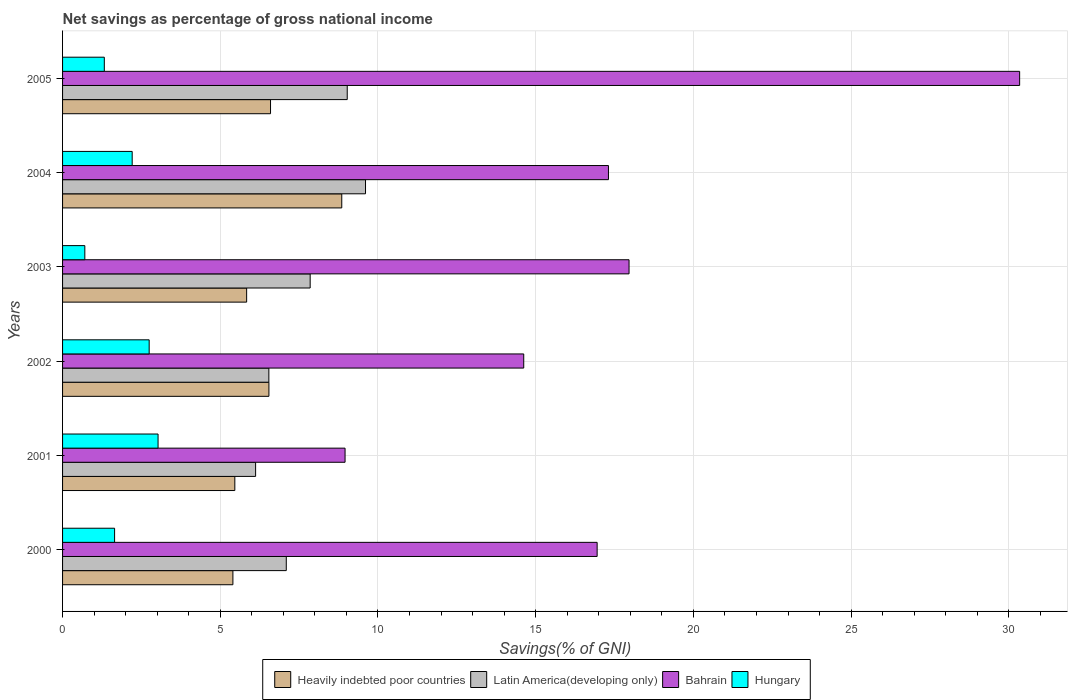How many groups of bars are there?
Offer a very short reply. 6. Are the number of bars on each tick of the Y-axis equal?
Provide a succinct answer. Yes. How many bars are there on the 3rd tick from the top?
Ensure brevity in your answer.  4. What is the label of the 2nd group of bars from the top?
Make the answer very short. 2004. In how many cases, is the number of bars for a given year not equal to the number of legend labels?
Make the answer very short. 0. What is the total savings in Bahrain in 2002?
Offer a terse response. 14.62. Across all years, what is the maximum total savings in Bahrain?
Your answer should be very brief. 30.34. Across all years, what is the minimum total savings in Heavily indebted poor countries?
Ensure brevity in your answer.  5.4. What is the total total savings in Hungary in the graph?
Ensure brevity in your answer.  11.66. What is the difference between the total savings in Bahrain in 2000 and that in 2001?
Provide a short and direct response. 7.99. What is the difference between the total savings in Bahrain in 2004 and the total savings in Latin America(developing only) in 2003?
Provide a succinct answer. 9.46. What is the average total savings in Latin America(developing only) per year?
Give a very brief answer. 7.71. In the year 2004, what is the difference between the total savings in Heavily indebted poor countries and total savings in Hungary?
Your answer should be compact. 6.64. In how many years, is the total savings in Latin America(developing only) greater than 8 %?
Your response must be concise. 2. What is the ratio of the total savings in Latin America(developing only) in 2002 to that in 2004?
Give a very brief answer. 0.68. Is the total savings in Hungary in 2000 less than that in 2005?
Provide a succinct answer. No. What is the difference between the highest and the second highest total savings in Heavily indebted poor countries?
Provide a short and direct response. 2.26. What is the difference between the highest and the lowest total savings in Hungary?
Your answer should be very brief. 2.32. Is the sum of the total savings in Latin America(developing only) in 2000 and 2003 greater than the maximum total savings in Hungary across all years?
Your answer should be compact. Yes. Is it the case that in every year, the sum of the total savings in Hungary and total savings in Latin America(developing only) is greater than the sum of total savings in Bahrain and total savings in Heavily indebted poor countries?
Make the answer very short. Yes. What does the 2nd bar from the top in 2003 represents?
Keep it short and to the point. Bahrain. What does the 4th bar from the bottom in 2003 represents?
Your answer should be compact. Hungary. How many bars are there?
Keep it short and to the point. 24. Are all the bars in the graph horizontal?
Give a very brief answer. Yes. How many years are there in the graph?
Provide a short and direct response. 6. Are the values on the major ticks of X-axis written in scientific E-notation?
Keep it short and to the point. No. Does the graph contain any zero values?
Offer a very short reply. No. Does the graph contain grids?
Your response must be concise. Yes. How are the legend labels stacked?
Give a very brief answer. Horizontal. What is the title of the graph?
Keep it short and to the point. Net savings as percentage of gross national income. Does "Maldives" appear as one of the legend labels in the graph?
Ensure brevity in your answer.  No. What is the label or title of the X-axis?
Provide a short and direct response. Savings(% of GNI). What is the label or title of the Y-axis?
Make the answer very short. Years. What is the Savings(% of GNI) of Heavily indebted poor countries in 2000?
Offer a very short reply. 5.4. What is the Savings(% of GNI) in Latin America(developing only) in 2000?
Your response must be concise. 7.09. What is the Savings(% of GNI) of Bahrain in 2000?
Provide a short and direct response. 16.95. What is the Savings(% of GNI) in Hungary in 2000?
Offer a very short reply. 1.65. What is the Savings(% of GNI) in Heavily indebted poor countries in 2001?
Provide a succinct answer. 5.46. What is the Savings(% of GNI) of Latin America(developing only) in 2001?
Your answer should be very brief. 6.12. What is the Savings(% of GNI) in Bahrain in 2001?
Your answer should be compact. 8.96. What is the Savings(% of GNI) of Hungary in 2001?
Offer a terse response. 3.03. What is the Savings(% of GNI) of Heavily indebted poor countries in 2002?
Keep it short and to the point. 6.54. What is the Savings(% of GNI) in Latin America(developing only) in 2002?
Offer a terse response. 6.54. What is the Savings(% of GNI) of Bahrain in 2002?
Your response must be concise. 14.62. What is the Savings(% of GNI) of Hungary in 2002?
Keep it short and to the point. 2.75. What is the Savings(% of GNI) in Heavily indebted poor countries in 2003?
Keep it short and to the point. 5.84. What is the Savings(% of GNI) in Latin America(developing only) in 2003?
Provide a short and direct response. 7.85. What is the Savings(% of GNI) of Bahrain in 2003?
Your response must be concise. 17.96. What is the Savings(% of GNI) in Hungary in 2003?
Give a very brief answer. 0.71. What is the Savings(% of GNI) in Heavily indebted poor countries in 2004?
Offer a terse response. 8.85. What is the Savings(% of GNI) of Latin America(developing only) in 2004?
Your answer should be compact. 9.6. What is the Savings(% of GNI) of Bahrain in 2004?
Provide a succinct answer. 17.31. What is the Savings(% of GNI) of Hungary in 2004?
Provide a succinct answer. 2.21. What is the Savings(% of GNI) of Heavily indebted poor countries in 2005?
Your answer should be very brief. 6.59. What is the Savings(% of GNI) of Latin America(developing only) in 2005?
Your answer should be compact. 9.02. What is the Savings(% of GNI) of Bahrain in 2005?
Make the answer very short. 30.34. What is the Savings(% of GNI) of Hungary in 2005?
Offer a very short reply. 1.32. Across all years, what is the maximum Savings(% of GNI) of Heavily indebted poor countries?
Your answer should be very brief. 8.85. Across all years, what is the maximum Savings(% of GNI) in Latin America(developing only)?
Give a very brief answer. 9.6. Across all years, what is the maximum Savings(% of GNI) of Bahrain?
Your answer should be very brief. 30.34. Across all years, what is the maximum Savings(% of GNI) in Hungary?
Your response must be concise. 3.03. Across all years, what is the minimum Savings(% of GNI) in Heavily indebted poor countries?
Keep it short and to the point. 5.4. Across all years, what is the minimum Savings(% of GNI) of Latin America(developing only)?
Make the answer very short. 6.12. Across all years, what is the minimum Savings(% of GNI) of Bahrain?
Ensure brevity in your answer.  8.96. Across all years, what is the minimum Savings(% of GNI) in Hungary?
Ensure brevity in your answer.  0.71. What is the total Savings(% of GNI) in Heavily indebted poor countries in the graph?
Give a very brief answer. 38.68. What is the total Savings(% of GNI) in Latin America(developing only) in the graph?
Ensure brevity in your answer.  46.23. What is the total Savings(% of GNI) of Bahrain in the graph?
Provide a short and direct response. 106.13. What is the total Savings(% of GNI) of Hungary in the graph?
Make the answer very short. 11.66. What is the difference between the Savings(% of GNI) in Heavily indebted poor countries in 2000 and that in 2001?
Keep it short and to the point. -0.06. What is the difference between the Savings(% of GNI) of Latin America(developing only) in 2000 and that in 2001?
Keep it short and to the point. 0.97. What is the difference between the Savings(% of GNI) of Bahrain in 2000 and that in 2001?
Provide a succinct answer. 7.99. What is the difference between the Savings(% of GNI) of Hungary in 2000 and that in 2001?
Provide a short and direct response. -1.38. What is the difference between the Savings(% of GNI) of Heavily indebted poor countries in 2000 and that in 2002?
Keep it short and to the point. -1.14. What is the difference between the Savings(% of GNI) of Latin America(developing only) in 2000 and that in 2002?
Give a very brief answer. 0.55. What is the difference between the Savings(% of GNI) in Bahrain in 2000 and that in 2002?
Provide a succinct answer. 2.33. What is the difference between the Savings(% of GNI) of Hungary in 2000 and that in 2002?
Make the answer very short. -1.1. What is the difference between the Savings(% of GNI) of Heavily indebted poor countries in 2000 and that in 2003?
Give a very brief answer. -0.44. What is the difference between the Savings(% of GNI) of Latin America(developing only) in 2000 and that in 2003?
Offer a terse response. -0.76. What is the difference between the Savings(% of GNI) in Bahrain in 2000 and that in 2003?
Provide a short and direct response. -1.01. What is the difference between the Savings(% of GNI) in Hungary in 2000 and that in 2003?
Your answer should be very brief. 0.94. What is the difference between the Savings(% of GNI) in Heavily indebted poor countries in 2000 and that in 2004?
Ensure brevity in your answer.  -3.45. What is the difference between the Savings(% of GNI) in Latin America(developing only) in 2000 and that in 2004?
Provide a succinct answer. -2.51. What is the difference between the Savings(% of GNI) of Bahrain in 2000 and that in 2004?
Provide a succinct answer. -0.36. What is the difference between the Savings(% of GNI) in Hungary in 2000 and that in 2004?
Give a very brief answer. -0.56. What is the difference between the Savings(% of GNI) of Heavily indebted poor countries in 2000 and that in 2005?
Make the answer very short. -1.19. What is the difference between the Savings(% of GNI) of Latin America(developing only) in 2000 and that in 2005?
Your response must be concise. -1.93. What is the difference between the Savings(% of GNI) in Bahrain in 2000 and that in 2005?
Provide a short and direct response. -13.39. What is the difference between the Savings(% of GNI) of Hungary in 2000 and that in 2005?
Give a very brief answer. 0.33. What is the difference between the Savings(% of GNI) of Heavily indebted poor countries in 2001 and that in 2002?
Your response must be concise. -1.08. What is the difference between the Savings(% of GNI) in Latin America(developing only) in 2001 and that in 2002?
Your answer should be very brief. -0.42. What is the difference between the Savings(% of GNI) of Bahrain in 2001 and that in 2002?
Your answer should be compact. -5.66. What is the difference between the Savings(% of GNI) of Hungary in 2001 and that in 2002?
Give a very brief answer. 0.28. What is the difference between the Savings(% of GNI) in Heavily indebted poor countries in 2001 and that in 2003?
Your response must be concise. -0.37. What is the difference between the Savings(% of GNI) of Latin America(developing only) in 2001 and that in 2003?
Give a very brief answer. -1.73. What is the difference between the Savings(% of GNI) of Bahrain in 2001 and that in 2003?
Provide a short and direct response. -9. What is the difference between the Savings(% of GNI) of Hungary in 2001 and that in 2003?
Make the answer very short. 2.32. What is the difference between the Savings(% of GNI) in Heavily indebted poor countries in 2001 and that in 2004?
Provide a short and direct response. -3.39. What is the difference between the Savings(% of GNI) of Latin America(developing only) in 2001 and that in 2004?
Keep it short and to the point. -3.48. What is the difference between the Savings(% of GNI) of Bahrain in 2001 and that in 2004?
Ensure brevity in your answer.  -8.35. What is the difference between the Savings(% of GNI) in Hungary in 2001 and that in 2004?
Offer a very short reply. 0.82. What is the difference between the Savings(% of GNI) in Heavily indebted poor countries in 2001 and that in 2005?
Your answer should be very brief. -1.13. What is the difference between the Savings(% of GNI) of Latin America(developing only) in 2001 and that in 2005?
Your response must be concise. -2.9. What is the difference between the Savings(% of GNI) of Bahrain in 2001 and that in 2005?
Offer a terse response. -21.39. What is the difference between the Savings(% of GNI) in Hungary in 2001 and that in 2005?
Offer a terse response. 1.7. What is the difference between the Savings(% of GNI) in Heavily indebted poor countries in 2002 and that in 2003?
Your response must be concise. 0.71. What is the difference between the Savings(% of GNI) of Latin America(developing only) in 2002 and that in 2003?
Your response must be concise. -1.31. What is the difference between the Savings(% of GNI) in Bahrain in 2002 and that in 2003?
Make the answer very short. -3.34. What is the difference between the Savings(% of GNI) in Hungary in 2002 and that in 2003?
Your answer should be compact. 2.04. What is the difference between the Savings(% of GNI) in Heavily indebted poor countries in 2002 and that in 2004?
Give a very brief answer. -2.31. What is the difference between the Savings(% of GNI) of Latin America(developing only) in 2002 and that in 2004?
Your answer should be very brief. -3.06. What is the difference between the Savings(% of GNI) in Bahrain in 2002 and that in 2004?
Keep it short and to the point. -2.69. What is the difference between the Savings(% of GNI) of Hungary in 2002 and that in 2004?
Provide a succinct answer. 0.54. What is the difference between the Savings(% of GNI) of Heavily indebted poor countries in 2002 and that in 2005?
Keep it short and to the point. -0.05. What is the difference between the Savings(% of GNI) of Latin America(developing only) in 2002 and that in 2005?
Provide a short and direct response. -2.48. What is the difference between the Savings(% of GNI) of Bahrain in 2002 and that in 2005?
Give a very brief answer. -15.72. What is the difference between the Savings(% of GNI) in Hungary in 2002 and that in 2005?
Provide a short and direct response. 1.42. What is the difference between the Savings(% of GNI) in Heavily indebted poor countries in 2003 and that in 2004?
Provide a succinct answer. -3.02. What is the difference between the Savings(% of GNI) in Latin America(developing only) in 2003 and that in 2004?
Ensure brevity in your answer.  -1.75. What is the difference between the Savings(% of GNI) of Bahrain in 2003 and that in 2004?
Offer a terse response. 0.65. What is the difference between the Savings(% of GNI) of Hungary in 2003 and that in 2004?
Make the answer very short. -1.5. What is the difference between the Savings(% of GNI) of Heavily indebted poor countries in 2003 and that in 2005?
Ensure brevity in your answer.  -0.76. What is the difference between the Savings(% of GNI) of Latin America(developing only) in 2003 and that in 2005?
Give a very brief answer. -1.17. What is the difference between the Savings(% of GNI) in Bahrain in 2003 and that in 2005?
Your answer should be compact. -12.38. What is the difference between the Savings(% of GNI) of Hungary in 2003 and that in 2005?
Your answer should be compact. -0.62. What is the difference between the Savings(% of GNI) in Heavily indebted poor countries in 2004 and that in 2005?
Provide a succinct answer. 2.26. What is the difference between the Savings(% of GNI) of Latin America(developing only) in 2004 and that in 2005?
Make the answer very short. 0.58. What is the difference between the Savings(% of GNI) of Bahrain in 2004 and that in 2005?
Provide a short and direct response. -13.04. What is the difference between the Savings(% of GNI) in Hungary in 2004 and that in 2005?
Make the answer very short. 0.88. What is the difference between the Savings(% of GNI) of Heavily indebted poor countries in 2000 and the Savings(% of GNI) of Latin America(developing only) in 2001?
Give a very brief answer. -0.72. What is the difference between the Savings(% of GNI) in Heavily indebted poor countries in 2000 and the Savings(% of GNI) in Bahrain in 2001?
Ensure brevity in your answer.  -3.56. What is the difference between the Savings(% of GNI) in Heavily indebted poor countries in 2000 and the Savings(% of GNI) in Hungary in 2001?
Keep it short and to the point. 2.37. What is the difference between the Savings(% of GNI) in Latin America(developing only) in 2000 and the Savings(% of GNI) in Bahrain in 2001?
Offer a terse response. -1.86. What is the difference between the Savings(% of GNI) of Latin America(developing only) in 2000 and the Savings(% of GNI) of Hungary in 2001?
Keep it short and to the point. 4.06. What is the difference between the Savings(% of GNI) in Bahrain in 2000 and the Savings(% of GNI) in Hungary in 2001?
Provide a short and direct response. 13.92. What is the difference between the Savings(% of GNI) of Heavily indebted poor countries in 2000 and the Savings(% of GNI) of Latin America(developing only) in 2002?
Offer a terse response. -1.14. What is the difference between the Savings(% of GNI) in Heavily indebted poor countries in 2000 and the Savings(% of GNI) in Bahrain in 2002?
Make the answer very short. -9.22. What is the difference between the Savings(% of GNI) in Heavily indebted poor countries in 2000 and the Savings(% of GNI) in Hungary in 2002?
Provide a succinct answer. 2.65. What is the difference between the Savings(% of GNI) in Latin America(developing only) in 2000 and the Savings(% of GNI) in Bahrain in 2002?
Keep it short and to the point. -7.53. What is the difference between the Savings(% of GNI) in Latin America(developing only) in 2000 and the Savings(% of GNI) in Hungary in 2002?
Offer a terse response. 4.35. What is the difference between the Savings(% of GNI) in Bahrain in 2000 and the Savings(% of GNI) in Hungary in 2002?
Your response must be concise. 14.2. What is the difference between the Savings(% of GNI) in Heavily indebted poor countries in 2000 and the Savings(% of GNI) in Latin America(developing only) in 2003?
Give a very brief answer. -2.45. What is the difference between the Savings(% of GNI) in Heavily indebted poor countries in 2000 and the Savings(% of GNI) in Bahrain in 2003?
Your answer should be very brief. -12.56. What is the difference between the Savings(% of GNI) in Heavily indebted poor countries in 2000 and the Savings(% of GNI) in Hungary in 2003?
Your answer should be very brief. 4.69. What is the difference between the Savings(% of GNI) in Latin America(developing only) in 2000 and the Savings(% of GNI) in Bahrain in 2003?
Give a very brief answer. -10.87. What is the difference between the Savings(% of GNI) of Latin America(developing only) in 2000 and the Savings(% of GNI) of Hungary in 2003?
Your response must be concise. 6.39. What is the difference between the Savings(% of GNI) in Bahrain in 2000 and the Savings(% of GNI) in Hungary in 2003?
Offer a very short reply. 16.24. What is the difference between the Savings(% of GNI) in Heavily indebted poor countries in 2000 and the Savings(% of GNI) in Latin America(developing only) in 2004?
Make the answer very short. -4.2. What is the difference between the Savings(% of GNI) in Heavily indebted poor countries in 2000 and the Savings(% of GNI) in Bahrain in 2004?
Keep it short and to the point. -11.91. What is the difference between the Savings(% of GNI) of Heavily indebted poor countries in 2000 and the Savings(% of GNI) of Hungary in 2004?
Your response must be concise. 3.19. What is the difference between the Savings(% of GNI) of Latin America(developing only) in 2000 and the Savings(% of GNI) of Bahrain in 2004?
Provide a succinct answer. -10.21. What is the difference between the Savings(% of GNI) in Latin America(developing only) in 2000 and the Savings(% of GNI) in Hungary in 2004?
Give a very brief answer. 4.88. What is the difference between the Savings(% of GNI) in Bahrain in 2000 and the Savings(% of GNI) in Hungary in 2004?
Provide a succinct answer. 14.74. What is the difference between the Savings(% of GNI) of Heavily indebted poor countries in 2000 and the Savings(% of GNI) of Latin America(developing only) in 2005?
Offer a very short reply. -3.62. What is the difference between the Savings(% of GNI) of Heavily indebted poor countries in 2000 and the Savings(% of GNI) of Bahrain in 2005?
Provide a short and direct response. -24.94. What is the difference between the Savings(% of GNI) of Heavily indebted poor countries in 2000 and the Savings(% of GNI) of Hungary in 2005?
Keep it short and to the point. 4.08. What is the difference between the Savings(% of GNI) of Latin America(developing only) in 2000 and the Savings(% of GNI) of Bahrain in 2005?
Give a very brief answer. -23.25. What is the difference between the Savings(% of GNI) in Latin America(developing only) in 2000 and the Savings(% of GNI) in Hungary in 2005?
Offer a very short reply. 5.77. What is the difference between the Savings(% of GNI) of Bahrain in 2000 and the Savings(% of GNI) of Hungary in 2005?
Your answer should be very brief. 15.62. What is the difference between the Savings(% of GNI) of Heavily indebted poor countries in 2001 and the Savings(% of GNI) of Latin America(developing only) in 2002?
Provide a succinct answer. -1.08. What is the difference between the Savings(% of GNI) in Heavily indebted poor countries in 2001 and the Savings(% of GNI) in Bahrain in 2002?
Provide a succinct answer. -9.16. What is the difference between the Savings(% of GNI) in Heavily indebted poor countries in 2001 and the Savings(% of GNI) in Hungary in 2002?
Make the answer very short. 2.72. What is the difference between the Savings(% of GNI) in Latin America(developing only) in 2001 and the Savings(% of GNI) in Hungary in 2002?
Your answer should be very brief. 3.37. What is the difference between the Savings(% of GNI) in Bahrain in 2001 and the Savings(% of GNI) in Hungary in 2002?
Provide a succinct answer. 6.21. What is the difference between the Savings(% of GNI) in Heavily indebted poor countries in 2001 and the Savings(% of GNI) in Latin America(developing only) in 2003?
Your answer should be compact. -2.39. What is the difference between the Savings(% of GNI) in Heavily indebted poor countries in 2001 and the Savings(% of GNI) in Bahrain in 2003?
Your answer should be very brief. -12.5. What is the difference between the Savings(% of GNI) of Heavily indebted poor countries in 2001 and the Savings(% of GNI) of Hungary in 2003?
Provide a succinct answer. 4.76. What is the difference between the Savings(% of GNI) in Latin America(developing only) in 2001 and the Savings(% of GNI) in Bahrain in 2003?
Offer a very short reply. -11.84. What is the difference between the Savings(% of GNI) of Latin America(developing only) in 2001 and the Savings(% of GNI) of Hungary in 2003?
Give a very brief answer. 5.41. What is the difference between the Savings(% of GNI) of Bahrain in 2001 and the Savings(% of GNI) of Hungary in 2003?
Ensure brevity in your answer.  8.25. What is the difference between the Savings(% of GNI) of Heavily indebted poor countries in 2001 and the Savings(% of GNI) of Latin America(developing only) in 2004?
Keep it short and to the point. -4.14. What is the difference between the Savings(% of GNI) of Heavily indebted poor countries in 2001 and the Savings(% of GNI) of Bahrain in 2004?
Keep it short and to the point. -11.85. What is the difference between the Savings(% of GNI) in Heavily indebted poor countries in 2001 and the Savings(% of GNI) in Hungary in 2004?
Keep it short and to the point. 3.25. What is the difference between the Savings(% of GNI) of Latin America(developing only) in 2001 and the Savings(% of GNI) of Bahrain in 2004?
Ensure brevity in your answer.  -11.19. What is the difference between the Savings(% of GNI) in Latin America(developing only) in 2001 and the Savings(% of GNI) in Hungary in 2004?
Provide a short and direct response. 3.91. What is the difference between the Savings(% of GNI) of Bahrain in 2001 and the Savings(% of GNI) of Hungary in 2004?
Your response must be concise. 6.75. What is the difference between the Savings(% of GNI) in Heavily indebted poor countries in 2001 and the Savings(% of GNI) in Latin America(developing only) in 2005?
Offer a terse response. -3.56. What is the difference between the Savings(% of GNI) of Heavily indebted poor countries in 2001 and the Savings(% of GNI) of Bahrain in 2005?
Ensure brevity in your answer.  -24.88. What is the difference between the Savings(% of GNI) of Heavily indebted poor countries in 2001 and the Savings(% of GNI) of Hungary in 2005?
Offer a terse response. 4.14. What is the difference between the Savings(% of GNI) in Latin America(developing only) in 2001 and the Savings(% of GNI) in Bahrain in 2005?
Give a very brief answer. -24.22. What is the difference between the Savings(% of GNI) in Latin America(developing only) in 2001 and the Savings(% of GNI) in Hungary in 2005?
Make the answer very short. 4.8. What is the difference between the Savings(% of GNI) of Bahrain in 2001 and the Savings(% of GNI) of Hungary in 2005?
Your answer should be very brief. 7.63. What is the difference between the Savings(% of GNI) of Heavily indebted poor countries in 2002 and the Savings(% of GNI) of Latin America(developing only) in 2003?
Keep it short and to the point. -1.31. What is the difference between the Savings(% of GNI) of Heavily indebted poor countries in 2002 and the Savings(% of GNI) of Bahrain in 2003?
Your response must be concise. -11.42. What is the difference between the Savings(% of GNI) in Heavily indebted poor countries in 2002 and the Savings(% of GNI) in Hungary in 2003?
Your answer should be very brief. 5.84. What is the difference between the Savings(% of GNI) in Latin America(developing only) in 2002 and the Savings(% of GNI) in Bahrain in 2003?
Keep it short and to the point. -11.42. What is the difference between the Savings(% of GNI) in Latin America(developing only) in 2002 and the Savings(% of GNI) in Hungary in 2003?
Your response must be concise. 5.83. What is the difference between the Savings(% of GNI) in Bahrain in 2002 and the Savings(% of GNI) in Hungary in 2003?
Offer a terse response. 13.91. What is the difference between the Savings(% of GNI) in Heavily indebted poor countries in 2002 and the Savings(% of GNI) in Latin America(developing only) in 2004?
Your response must be concise. -3.06. What is the difference between the Savings(% of GNI) in Heavily indebted poor countries in 2002 and the Savings(% of GNI) in Bahrain in 2004?
Keep it short and to the point. -10.76. What is the difference between the Savings(% of GNI) in Heavily indebted poor countries in 2002 and the Savings(% of GNI) in Hungary in 2004?
Keep it short and to the point. 4.33. What is the difference between the Savings(% of GNI) in Latin America(developing only) in 2002 and the Savings(% of GNI) in Bahrain in 2004?
Offer a very short reply. -10.77. What is the difference between the Savings(% of GNI) of Latin America(developing only) in 2002 and the Savings(% of GNI) of Hungary in 2004?
Give a very brief answer. 4.33. What is the difference between the Savings(% of GNI) in Bahrain in 2002 and the Savings(% of GNI) in Hungary in 2004?
Offer a terse response. 12.41. What is the difference between the Savings(% of GNI) of Heavily indebted poor countries in 2002 and the Savings(% of GNI) of Latin America(developing only) in 2005?
Offer a terse response. -2.48. What is the difference between the Savings(% of GNI) in Heavily indebted poor countries in 2002 and the Savings(% of GNI) in Bahrain in 2005?
Your answer should be compact. -23.8. What is the difference between the Savings(% of GNI) in Heavily indebted poor countries in 2002 and the Savings(% of GNI) in Hungary in 2005?
Your response must be concise. 5.22. What is the difference between the Savings(% of GNI) of Latin America(developing only) in 2002 and the Savings(% of GNI) of Bahrain in 2005?
Provide a short and direct response. -23.8. What is the difference between the Savings(% of GNI) of Latin America(developing only) in 2002 and the Savings(% of GNI) of Hungary in 2005?
Your answer should be very brief. 5.22. What is the difference between the Savings(% of GNI) of Bahrain in 2002 and the Savings(% of GNI) of Hungary in 2005?
Your response must be concise. 13.3. What is the difference between the Savings(% of GNI) in Heavily indebted poor countries in 2003 and the Savings(% of GNI) in Latin America(developing only) in 2004?
Give a very brief answer. -3.77. What is the difference between the Savings(% of GNI) of Heavily indebted poor countries in 2003 and the Savings(% of GNI) of Bahrain in 2004?
Your answer should be compact. -11.47. What is the difference between the Savings(% of GNI) of Heavily indebted poor countries in 2003 and the Savings(% of GNI) of Hungary in 2004?
Make the answer very short. 3.63. What is the difference between the Savings(% of GNI) of Latin America(developing only) in 2003 and the Savings(% of GNI) of Bahrain in 2004?
Offer a terse response. -9.46. What is the difference between the Savings(% of GNI) in Latin America(developing only) in 2003 and the Savings(% of GNI) in Hungary in 2004?
Offer a very short reply. 5.64. What is the difference between the Savings(% of GNI) in Bahrain in 2003 and the Savings(% of GNI) in Hungary in 2004?
Provide a succinct answer. 15.75. What is the difference between the Savings(% of GNI) of Heavily indebted poor countries in 2003 and the Savings(% of GNI) of Latin America(developing only) in 2005?
Offer a very short reply. -3.19. What is the difference between the Savings(% of GNI) in Heavily indebted poor countries in 2003 and the Savings(% of GNI) in Bahrain in 2005?
Give a very brief answer. -24.51. What is the difference between the Savings(% of GNI) in Heavily indebted poor countries in 2003 and the Savings(% of GNI) in Hungary in 2005?
Your answer should be compact. 4.51. What is the difference between the Savings(% of GNI) of Latin America(developing only) in 2003 and the Savings(% of GNI) of Bahrain in 2005?
Offer a terse response. -22.49. What is the difference between the Savings(% of GNI) in Latin America(developing only) in 2003 and the Savings(% of GNI) in Hungary in 2005?
Your response must be concise. 6.53. What is the difference between the Savings(% of GNI) of Bahrain in 2003 and the Savings(% of GNI) of Hungary in 2005?
Provide a short and direct response. 16.64. What is the difference between the Savings(% of GNI) in Heavily indebted poor countries in 2004 and the Savings(% of GNI) in Latin America(developing only) in 2005?
Ensure brevity in your answer.  -0.17. What is the difference between the Savings(% of GNI) in Heavily indebted poor countries in 2004 and the Savings(% of GNI) in Bahrain in 2005?
Provide a succinct answer. -21.49. What is the difference between the Savings(% of GNI) in Heavily indebted poor countries in 2004 and the Savings(% of GNI) in Hungary in 2005?
Offer a very short reply. 7.53. What is the difference between the Savings(% of GNI) of Latin America(developing only) in 2004 and the Savings(% of GNI) of Bahrain in 2005?
Give a very brief answer. -20.74. What is the difference between the Savings(% of GNI) in Latin America(developing only) in 2004 and the Savings(% of GNI) in Hungary in 2005?
Your answer should be compact. 8.28. What is the difference between the Savings(% of GNI) in Bahrain in 2004 and the Savings(% of GNI) in Hungary in 2005?
Provide a short and direct response. 15.98. What is the average Savings(% of GNI) in Heavily indebted poor countries per year?
Offer a terse response. 6.45. What is the average Savings(% of GNI) of Latin America(developing only) per year?
Your response must be concise. 7.71. What is the average Savings(% of GNI) in Bahrain per year?
Offer a terse response. 17.69. What is the average Savings(% of GNI) in Hungary per year?
Ensure brevity in your answer.  1.94. In the year 2000, what is the difference between the Savings(% of GNI) in Heavily indebted poor countries and Savings(% of GNI) in Latin America(developing only)?
Provide a short and direct response. -1.69. In the year 2000, what is the difference between the Savings(% of GNI) of Heavily indebted poor countries and Savings(% of GNI) of Bahrain?
Offer a very short reply. -11.55. In the year 2000, what is the difference between the Savings(% of GNI) in Heavily indebted poor countries and Savings(% of GNI) in Hungary?
Make the answer very short. 3.75. In the year 2000, what is the difference between the Savings(% of GNI) in Latin America(developing only) and Savings(% of GNI) in Bahrain?
Make the answer very short. -9.86. In the year 2000, what is the difference between the Savings(% of GNI) of Latin America(developing only) and Savings(% of GNI) of Hungary?
Offer a terse response. 5.44. In the year 2000, what is the difference between the Savings(% of GNI) of Bahrain and Savings(% of GNI) of Hungary?
Your response must be concise. 15.3. In the year 2001, what is the difference between the Savings(% of GNI) in Heavily indebted poor countries and Savings(% of GNI) in Latin America(developing only)?
Ensure brevity in your answer.  -0.66. In the year 2001, what is the difference between the Savings(% of GNI) in Heavily indebted poor countries and Savings(% of GNI) in Bahrain?
Offer a very short reply. -3.49. In the year 2001, what is the difference between the Savings(% of GNI) in Heavily indebted poor countries and Savings(% of GNI) in Hungary?
Make the answer very short. 2.43. In the year 2001, what is the difference between the Savings(% of GNI) in Latin America(developing only) and Savings(% of GNI) in Bahrain?
Give a very brief answer. -2.84. In the year 2001, what is the difference between the Savings(% of GNI) of Latin America(developing only) and Savings(% of GNI) of Hungary?
Your answer should be compact. 3.09. In the year 2001, what is the difference between the Savings(% of GNI) in Bahrain and Savings(% of GNI) in Hungary?
Your answer should be compact. 5.93. In the year 2002, what is the difference between the Savings(% of GNI) of Heavily indebted poor countries and Savings(% of GNI) of Latin America(developing only)?
Your answer should be very brief. 0. In the year 2002, what is the difference between the Savings(% of GNI) in Heavily indebted poor countries and Savings(% of GNI) in Bahrain?
Your answer should be very brief. -8.08. In the year 2002, what is the difference between the Savings(% of GNI) in Heavily indebted poor countries and Savings(% of GNI) in Hungary?
Offer a very short reply. 3.8. In the year 2002, what is the difference between the Savings(% of GNI) in Latin America(developing only) and Savings(% of GNI) in Bahrain?
Provide a succinct answer. -8.08. In the year 2002, what is the difference between the Savings(% of GNI) in Latin America(developing only) and Savings(% of GNI) in Hungary?
Your answer should be compact. 3.79. In the year 2002, what is the difference between the Savings(% of GNI) of Bahrain and Savings(% of GNI) of Hungary?
Provide a succinct answer. 11.87. In the year 2003, what is the difference between the Savings(% of GNI) of Heavily indebted poor countries and Savings(% of GNI) of Latin America(developing only)?
Make the answer very short. -2.01. In the year 2003, what is the difference between the Savings(% of GNI) in Heavily indebted poor countries and Savings(% of GNI) in Bahrain?
Make the answer very short. -12.12. In the year 2003, what is the difference between the Savings(% of GNI) in Heavily indebted poor countries and Savings(% of GNI) in Hungary?
Give a very brief answer. 5.13. In the year 2003, what is the difference between the Savings(% of GNI) of Latin America(developing only) and Savings(% of GNI) of Bahrain?
Offer a terse response. -10.11. In the year 2003, what is the difference between the Savings(% of GNI) in Latin America(developing only) and Savings(% of GNI) in Hungary?
Offer a terse response. 7.14. In the year 2003, what is the difference between the Savings(% of GNI) in Bahrain and Savings(% of GNI) in Hungary?
Offer a very short reply. 17.25. In the year 2004, what is the difference between the Savings(% of GNI) of Heavily indebted poor countries and Savings(% of GNI) of Latin America(developing only)?
Offer a terse response. -0.75. In the year 2004, what is the difference between the Savings(% of GNI) in Heavily indebted poor countries and Savings(% of GNI) in Bahrain?
Ensure brevity in your answer.  -8.45. In the year 2004, what is the difference between the Savings(% of GNI) of Heavily indebted poor countries and Savings(% of GNI) of Hungary?
Ensure brevity in your answer.  6.64. In the year 2004, what is the difference between the Savings(% of GNI) of Latin America(developing only) and Savings(% of GNI) of Bahrain?
Keep it short and to the point. -7.7. In the year 2004, what is the difference between the Savings(% of GNI) in Latin America(developing only) and Savings(% of GNI) in Hungary?
Your answer should be very brief. 7.4. In the year 2004, what is the difference between the Savings(% of GNI) in Bahrain and Savings(% of GNI) in Hungary?
Keep it short and to the point. 15.1. In the year 2005, what is the difference between the Savings(% of GNI) of Heavily indebted poor countries and Savings(% of GNI) of Latin America(developing only)?
Keep it short and to the point. -2.43. In the year 2005, what is the difference between the Savings(% of GNI) in Heavily indebted poor countries and Savings(% of GNI) in Bahrain?
Provide a short and direct response. -23.75. In the year 2005, what is the difference between the Savings(% of GNI) in Heavily indebted poor countries and Savings(% of GNI) in Hungary?
Offer a terse response. 5.27. In the year 2005, what is the difference between the Savings(% of GNI) in Latin America(developing only) and Savings(% of GNI) in Bahrain?
Offer a very short reply. -21.32. In the year 2005, what is the difference between the Savings(% of GNI) of Latin America(developing only) and Savings(% of GNI) of Hungary?
Make the answer very short. 7.7. In the year 2005, what is the difference between the Savings(% of GNI) in Bahrain and Savings(% of GNI) in Hungary?
Provide a short and direct response. 29.02. What is the ratio of the Savings(% of GNI) of Latin America(developing only) in 2000 to that in 2001?
Your answer should be compact. 1.16. What is the ratio of the Savings(% of GNI) of Bahrain in 2000 to that in 2001?
Your answer should be very brief. 1.89. What is the ratio of the Savings(% of GNI) in Hungary in 2000 to that in 2001?
Give a very brief answer. 0.54. What is the ratio of the Savings(% of GNI) of Heavily indebted poor countries in 2000 to that in 2002?
Your response must be concise. 0.83. What is the ratio of the Savings(% of GNI) of Latin America(developing only) in 2000 to that in 2002?
Offer a very short reply. 1.08. What is the ratio of the Savings(% of GNI) of Bahrain in 2000 to that in 2002?
Make the answer very short. 1.16. What is the ratio of the Savings(% of GNI) in Hungary in 2000 to that in 2002?
Offer a very short reply. 0.6. What is the ratio of the Savings(% of GNI) of Heavily indebted poor countries in 2000 to that in 2003?
Offer a terse response. 0.93. What is the ratio of the Savings(% of GNI) of Latin America(developing only) in 2000 to that in 2003?
Give a very brief answer. 0.9. What is the ratio of the Savings(% of GNI) in Bahrain in 2000 to that in 2003?
Keep it short and to the point. 0.94. What is the ratio of the Savings(% of GNI) of Hungary in 2000 to that in 2003?
Your answer should be compact. 2.34. What is the ratio of the Savings(% of GNI) of Heavily indebted poor countries in 2000 to that in 2004?
Provide a short and direct response. 0.61. What is the ratio of the Savings(% of GNI) in Latin America(developing only) in 2000 to that in 2004?
Provide a short and direct response. 0.74. What is the ratio of the Savings(% of GNI) in Bahrain in 2000 to that in 2004?
Ensure brevity in your answer.  0.98. What is the ratio of the Savings(% of GNI) of Hungary in 2000 to that in 2004?
Offer a terse response. 0.75. What is the ratio of the Savings(% of GNI) of Heavily indebted poor countries in 2000 to that in 2005?
Your answer should be compact. 0.82. What is the ratio of the Savings(% of GNI) in Latin America(developing only) in 2000 to that in 2005?
Keep it short and to the point. 0.79. What is the ratio of the Savings(% of GNI) in Bahrain in 2000 to that in 2005?
Your response must be concise. 0.56. What is the ratio of the Savings(% of GNI) of Hungary in 2000 to that in 2005?
Give a very brief answer. 1.25. What is the ratio of the Savings(% of GNI) of Heavily indebted poor countries in 2001 to that in 2002?
Provide a succinct answer. 0.83. What is the ratio of the Savings(% of GNI) of Latin America(developing only) in 2001 to that in 2002?
Offer a very short reply. 0.94. What is the ratio of the Savings(% of GNI) of Bahrain in 2001 to that in 2002?
Your answer should be compact. 0.61. What is the ratio of the Savings(% of GNI) of Hungary in 2001 to that in 2002?
Keep it short and to the point. 1.1. What is the ratio of the Savings(% of GNI) of Heavily indebted poor countries in 2001 to that in 2003?
Your answer should be very brief. 0.94. What is the ratio of the Savings(% of GNI) of Latin America(developing only) in 2001 to that in 2003?
Your answer should be very brief. 0.78. What is the ratio of the Savings(% of GNI) of Bahrain in 2001 to that in 2003?
Give a very brief answer. 0.5. What is the ratio of the Savings(% of GNI) of Hungary in 2001 to that in 2003?
Your answer should be compact. 4.29. What is the ratio of the Savings(% of GNI) in Heavily indebted poor countries in 2001 to that in 2004?
Give a very brief answer. 0.62. What is the ratio of the Savings(% of GNI) of Latin America(developing only) in 2001 to that in 2004?
Keep it short and to the point. 0.64. What is the ratio of the Savings(% of GNI) of Bahrain in 2001 to that in 2004?
Ensure brevity in your answer.  0.52. What is the ratio of the Savings(% of GNI) in Hungary in 2001 to that in 2004?
Provide a short and direct response. 1.37. What is the ratio of the Savings(% of GNI) of Heavily indebted poor countries in 2001 to that in 2005?
Keep it short and to the point. 0.83. What is the ratio of the Savings(% of GNI) of Latin America(developing only) in 2001 to that in 2005?
Offer a terse response. 0.68. What is the ratio of the Savings(% of GNI) of Bahrain in 2001 to that in 2005?
Provide a short and direct response. 0.3. What is the ratio of the Savings(% of GNI) in Hungary in 2001 to that in 2005?
Provide a succinct answer. 2.29. What is the ratio of the Savings(% of GNI) in Heavily indebted poor countries in 2002 to that in 2003?
Give a very brief answer. 1.12. What is the ratio of the Savings(% of GNI) of Latin America(developing only) in 2002 to that in 2003?
Offer a terse response. 0.83. What is the ratio of the Savings(% of GNI) of Bahrain in 2002 to that in 2003?
Make the answer very short. 0.81. What is the ratio of the Savings(% of GNI) of Hungary in 2002 to that in 2003?
Offer a very short reply. 3.89. What is the ratio of the Savings(% of GNI) of Heavily indebted poor countries in 2002 to that in 2004?
Your response must be concise. 0.74. What is the ratio of the Savings(% of GNI) of Latin America(developing only) in 2002 to that in 2004?
Provide a succinct answer. 0.68. What is the ratio of the Savings(% of GNI) in Bahrain in 2002 to that in 2004?
Ensure brevity in your answer.  0.84. What is the ratio of the Savings(% of GNI) of Hungary in 2002 to that in 2004?
Your answer should be very brief. 1.24. What is the ratio of the Savings(% of GNI) in Heavily indebted poor countries in 2002 to that in 2005?
Provide a succinct answer. 0.99. What is the ratio of the Savings(% of GNI) of Latin America(developing only) in 2002 to that in 2005?
Your response must be concise. 0.72. What is the ratio of the Savings(% of GNI) of Bahrain in 2002 to that in 2005?
Ensure brevity in your answer.  0.48. What is the ratio of the Savings(% of GNI) in Hungary in 2002 to that in 2005?
Offer a terse response. 2.07. What is the ratio of the Savings(% of GNI) in Heavily indebted poor countries in 2003 to that in 2004?
Keep it short and to the point. 0.66. What is the ratio of the Savings(% of GNI) of Latin America(developing only) in 2003 to that in 2004?
Offer a terse response. 0.82. What is the ratio of the Savings(% of GNI) of Bahrain in 2003 to that in 2004?
Your response must be concise. 1.04. What is the ratio of the Savings(% of GNI) of Hungary in 2003 to that in 2004?
Provide a short and direct response. 0.32. What is the ratio of the Savings(% of GNI) of Heavily indebted poor countries in 2003 to that in 2005?
Provide a succinct answer. 0.89. What is the ratio of the Savings(% of GNI) in Latin America(developing only) in 2003 to that in 2005?
Provide a short and direct response. 0.87. What is the ratio of the Savings(% of GNI) of Bahrain in 2003 to that in 2005?
Offer a terse response. 0.59. What is the ratio of the Savings(% of GNI) of Hungary in 2003 to that in 2005?
Offer a very short reply. 0.53. What is the ratio of the Savings(% of GNI) of Heavily indebted poor countries in 2004 to that in 2005?
Your answer should be compact. 1.34. What is the ratio of the Savings(% of GNI) of Latin America(developing only) in 2004 to that in 2005?
Your answer should be very brief. 1.06. What is the ratio of the Savings(% of GNI) of Bahrain in 2004 to that in 2005?
Your answer should be compact. 0.57. What is the ratio of the Savings(% of GNI) of Hungary in 2004 to that in 2005?
Provide a short and direct response. 1.67. What is the difference between the highest and the second highest Savings(% of GNI) in Heavily indebted poor countries?
Give a very brief answer. 2.26. What is the difference between the highest and the second highest Savings(% of GNI) of Latin America(developing only)?
Keep it short and to the point. 0.58. What is the difference between the highest and the second highest Savings(% of GNI) in Bahrain?
Your answer should be very brief. 12.38. What is the difference between the highest and the second highest Savings(% of GNI) in Hungary?
Provide a succinct answer. 0.28. What is the difference between the highest and the lowest Savings(% of GNI) in Heavily indebted poor countries?
Give a very brief answer. 3.45. What is the difference between the highest and the lowest Savings(% of GNI) in Latin America(developing only)?
Provide a succinct answer. 3.48. What is the difference between the highest and the lowest Savings(% of GNI) in Bahrain?
Offer a very short reply. 21.39. What is the difference between the highest and the lowest Savings(% of GNI) in Hungary?
Your answer should be compact. 2.32. 